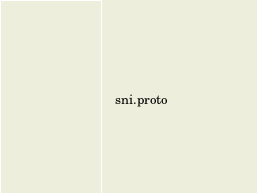<code> <loc_0><loc_0><loc_500><loc_500><_Bash_>    sni.proto
</code> 